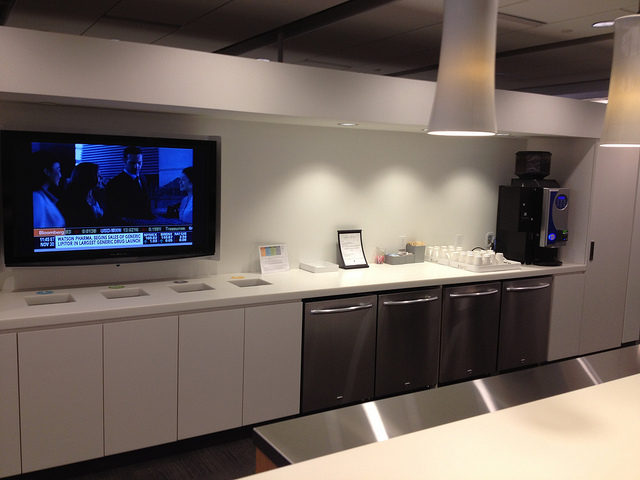<image>What kind of animal is displayed on the television? There is no animal displayed on the television. What kind of animal is displayed on the television? It cannot be determined what kind of animal is displayed on the television. There is no animal in the image. 